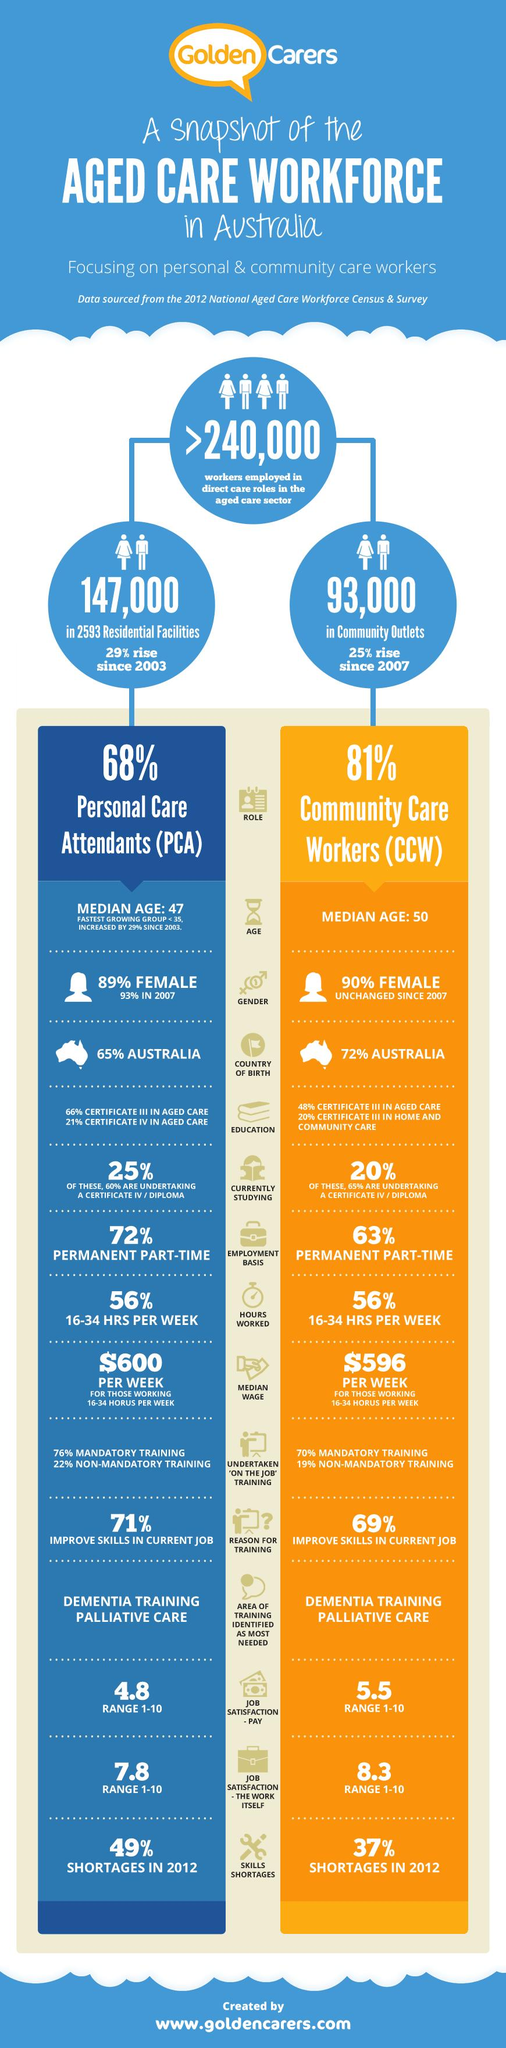Point out several critical features in this image. According to a recent study, approximately 90% of females working as Community care workers are employed in this field. According to a study conducted in 2012, personal care assistants were found to have a 49% skill shortage. According to the data, 81% of community care workers worked a certain percentage of hours. That percentage was 56%. Sixty-six percent of Personal Care Assistants in aged care have a Certificate III qualification. According to data, 48% of Community care workers hold a Certificate III in aged care. 